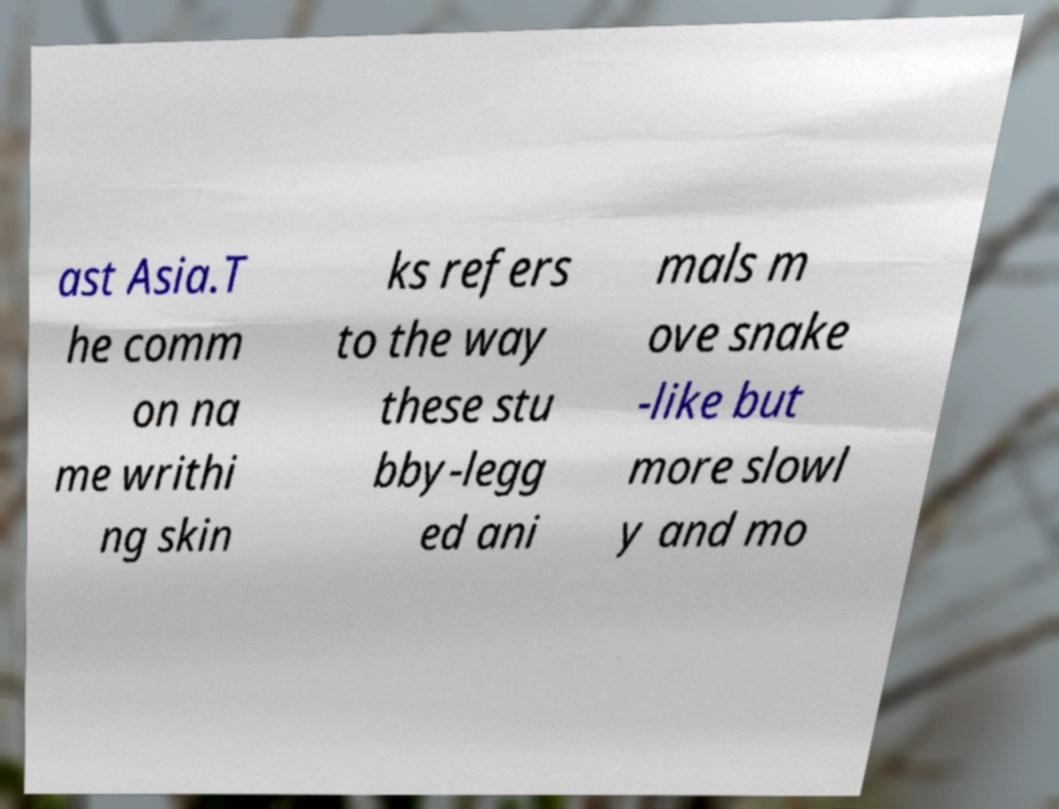Could you assist in decoding the text presented in this image and type it out clearly? ast Asia.T he comm on na me writhi ng skin ks refers to the way these stu bby-legg ed ani mals m ove snake -like but more slowl y and mo 